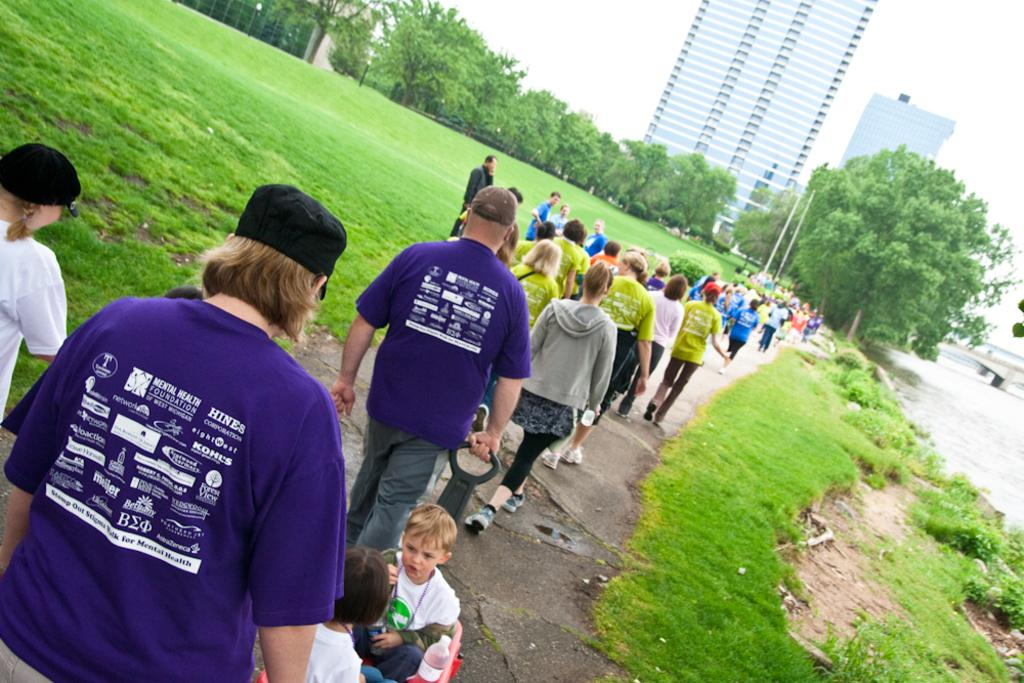Who can be seen in the image? There are people and children in the image. What is the environment like in the image? Grass, water, and trees are visible in the image, suggesting a natural setting. What are some people wearing in the image? Some people are wearing caps. What can be seen in the background of the image? There are buildings, trees, a bridge, and the sky visible in the background. What else is present in the distance? There are poles in the distance. How does the image promote peace? The image itself does not promote peace, as it is a visual representation and not an active promoter of any concept or idea. Is there any quicksand visible in the image? No, there is no quicksand present in the image. 